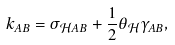Convert formula to latex. <formula><loc_0><loc_0><loc_500><loc_500>k _ { A B } = \sigma _ { \mathcal { H } A B } + \frac { 1 } { 2 } \theta _ { \mathcal { H } } \gamma _ { A B } ,</formula> 